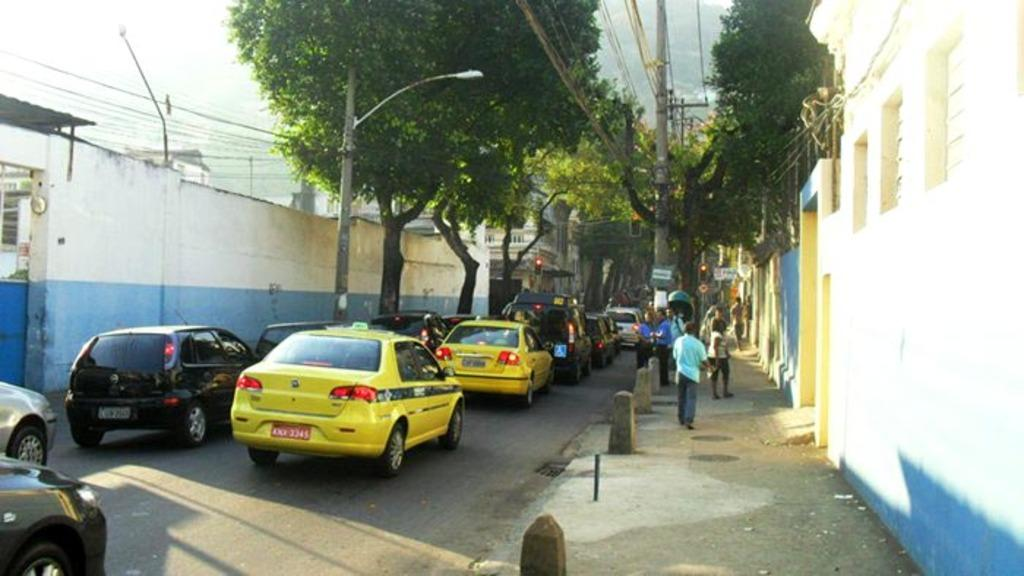What can be seen on the road in the image? There are vehicles on the road in the image. What is located on the right side of the image? There are people on the right side of the image. What type of natural elements are visible in the background of the image? There are trees in the background of the image. What type of man-made structures can be seen in the background of the image? There are poles, cables, and buildings in the background of the image. What type of lunch is being prepared by the worm in the image? There is no worm or lunch preparation visible in the image. How does the wash cycle affect the people on the right side of the image? There is no mention of a wash cycle or any washing activity in the image. 